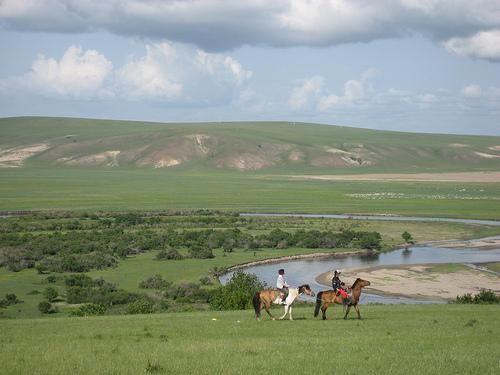What word would best describe their movement? Please explain your reasoning. walk. The horse appears to be moving slowly. 